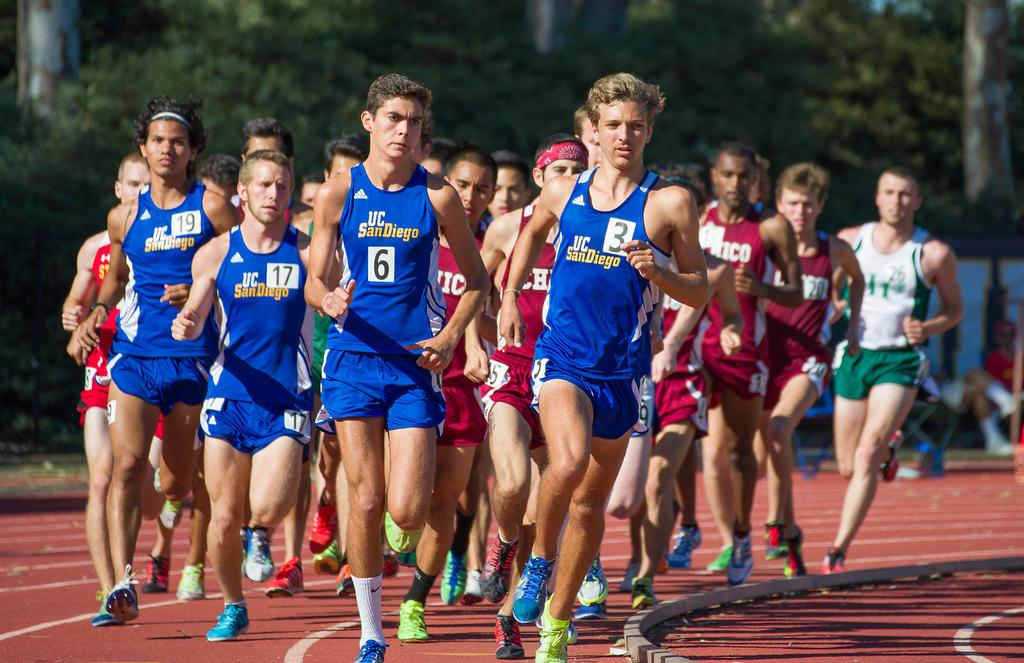What are the people in the image doing? There are people running on a mat and sitting on chairs in the image. Can you describe the setting of the image? The image shows people running on a mat and sitting on chairs, with trees visible in the background. What type of cart is being used to transport the design in the image? There is no cart or design present in the image; it features people running on a mat and sitting on chairs with trees in the background. 